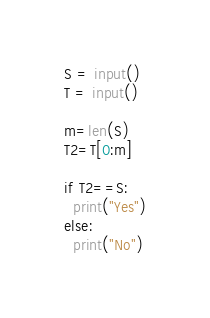Convert code to text. <code><loc_0><loc_0><loc_500><loc_500><_Python_>S = input()
T = input()

m=len(S)
T2=T[0:m]

if T2==S:
  print("Yes")
else:
  print("No")</code> 